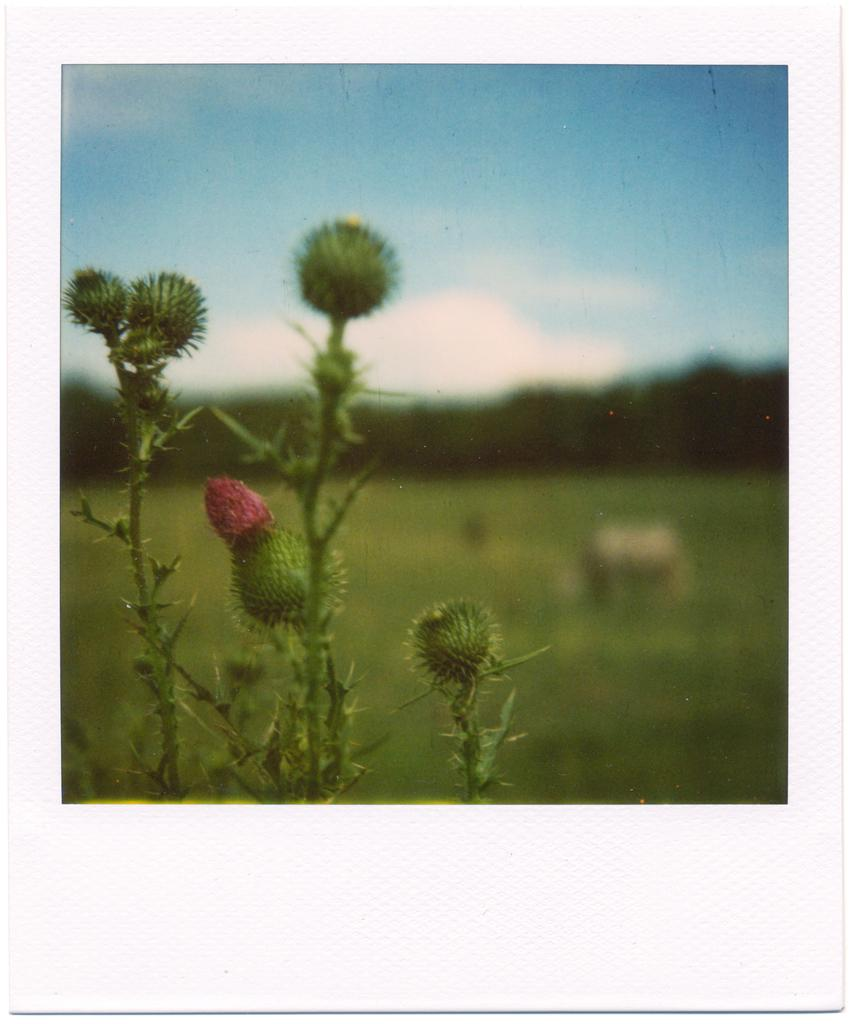What type of living organism is present in the image? There is a plant in the image. What part of the plant is visible in the image? The plant has a stem. What additional feature can be seen on the plant? The plant has fruit. What type of gold can be seen hanging from the branches of the plant in the image? There is no gold present in the image, and the plant does not have branches. 